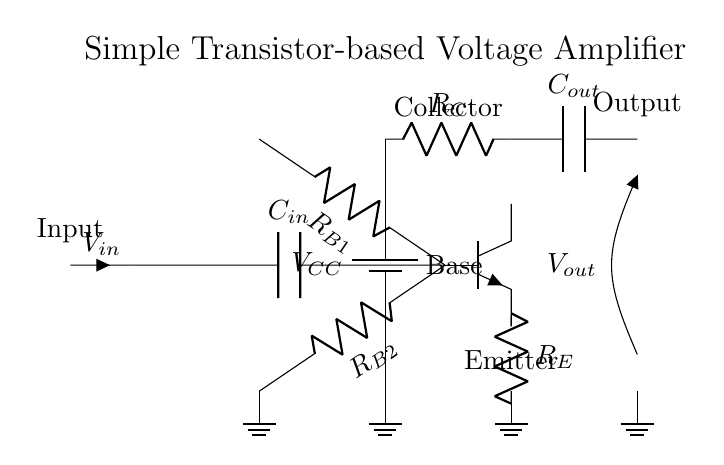What is the value of the collector resistor? The circuit diagram labels the collector resistor as R_C. The specific numeric value isn't provided, as typically the actual resistance value would depend on the design choice, but it is represented as R_C in the diagram.
Answer: R_C What component is used to couple the input signal? The capacitor labeled C_in is used to couple the input signal to the base of the transistor. It allows AC signals to pass while blocking DC components.
Answer: C_in How many base resistors are present in the circuit? There are two base resistors shown in the circuit: R_B1 and R_B2. These resistors help establish the correct biasing conditions for the transistor.
Answer: 2 What is the role of the emitter resistor? The emitter resistor, labeled R_E, provides stability to the amplifier by setting the emitter current. This plays a vital role in maintaining consistent operation despite variations in transistor parameters.
Answer: R_E What do C_out and C_in represent? C_out is the output coupling capacitor, ensuring that the output signal does not have a DC offset when reaching the load, while C_in is the input coupling capacitor, allowing the input AC signal to pass through.
Answer: C_out and C_in What is the power supply voltage in the circuit? The power supply voltage is represented as V_CC in the circuit diagram. Again, the exact numeric value is not specified, but it indicates the supply required for the amplifier operation.
Answer: V_CC 